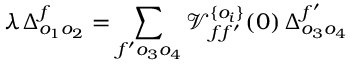Convert formula to latex. <formula><loc_0><loc_0><loc_500><loc_500>\lambda \Delta _ { o _ { 1 } o _ { 2 } } ^ { f } = \sum _ { f ^ { \prime } o _ { 3 } o _ { 4 } } \mathcal { V } _ { f f ^ { \prime } } ^ { \{ o _ { i } \} } ( 0 ) \, \Delta _ { o _ { 3 } o _ { 4 } } ^ { f ^ { \prime } }</formula> 